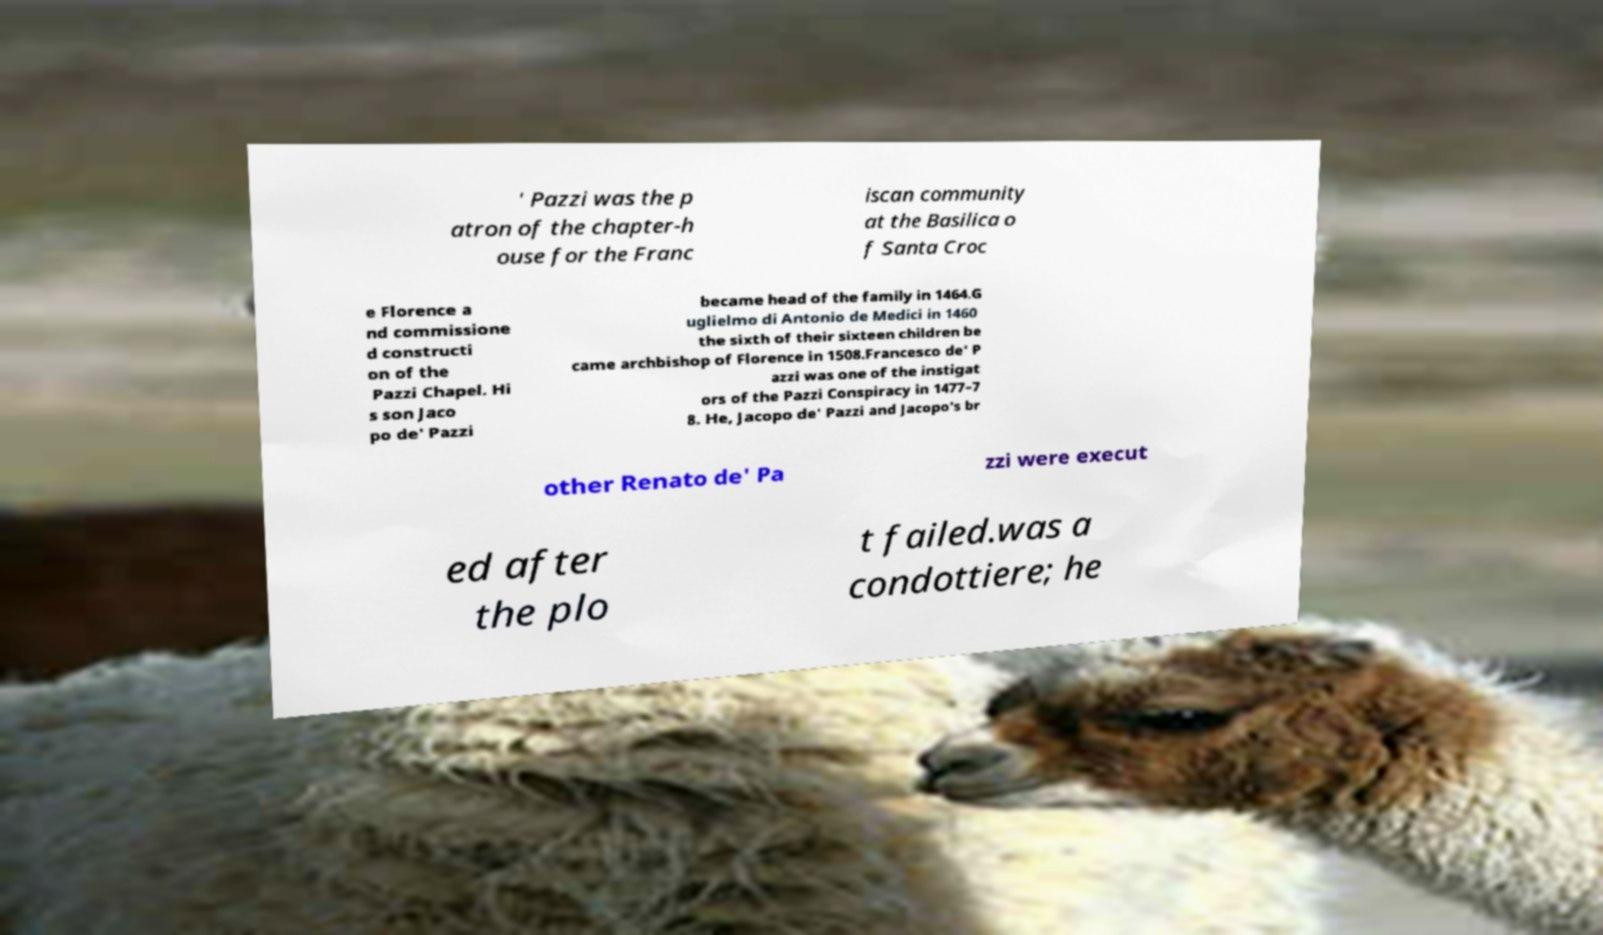There's text embedded in this image that I need extracted. Can you transcribe it verbatim? ' Pazzi was the p atron of the chapter-h ouse for the Franc iscan community at the Basilica o f Santa Croc e Florence a nd commissione d constructi on of the Pazzi Chapel. Hi s son Jaco po de' Pazzi became head of the family in 1464.G uglielmo di Antonio de Medici in 1460 the sixth of their sixteen children be came archbishop of Florence in 1508.Francesco de' P azzi was one of the instigat ors of the Pazzi Conspiracy in 1477–7 8. He, Jacopo de' Pazzi and Jacopo's br other Renato de' Pa zzi were execut ed after the plo t failed.was a condottiere; he 